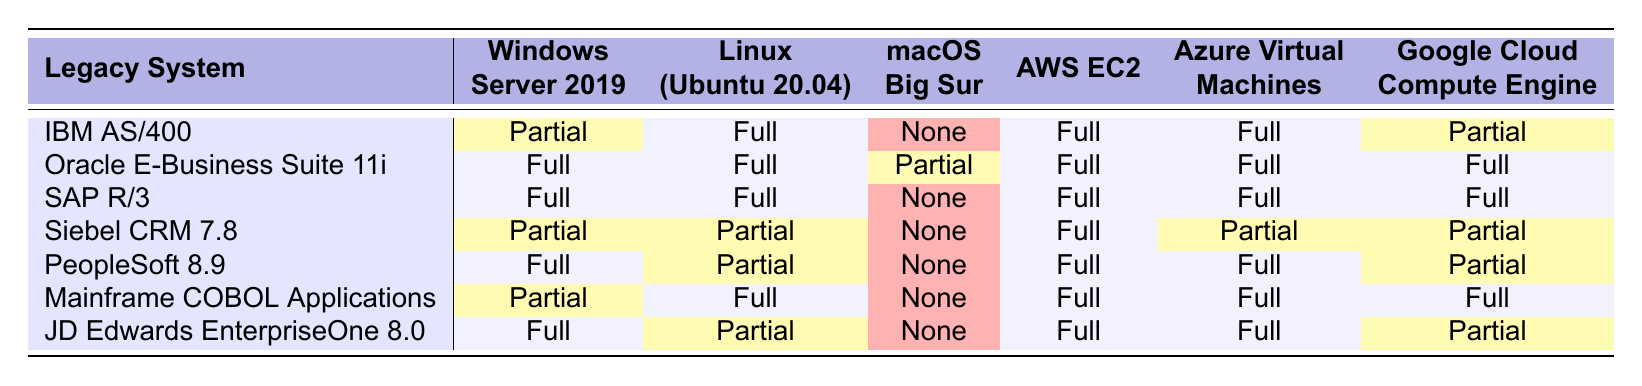What is the compatibility status of the IBM AS/400 with macOS Big Sur? According to the table, the IBM AS/400 shows a compatibility status of "None" with macOS Big Sur.
Answer: None Which legacy system has full compatibility across all modern platforms? Looking through the table, the legacy system Oracle E-Business Suite 11i has "Full" compatibility with all listed modern platforms.
Answer: Oracle E-Business Suite 11i How many legacy systems have partial compatibility with Windows Server 2019? From the table, IBM AS/400, Siebel CRM 7.8, Mainframe COBOL Applications, and JD Edwards EnterpriseOne 8.0 have "Partial" compatibility with Windows Server 2019, making a total of four systems.
Answer: Four Is there any legacy system that is fully compatible with both AWS EC2 and Azure Virtual Machines? By examining the table, we can see that all the systems except Siebel CRM 7.8 and PeopleSoft 8.9 are "Full" with AWS EC2 and Azure Virtual Machines. Hence, SAP R/3, Oracle E-Business Suite 11i, and Mainframe COBOL Applications are examples of such systems.
Answer: Yes What is the total number of legacy systems that have no compatibility with macOS Big Sur? The table indicates the legacy systems IBM AS/400, SAP R/3, Siebel CRM 7.8, PeopleSoft 8.9, Mainframe COBOL Applications, and JD Edwards EnterpriseOne 8.0 with "None" compatibility to macOS Big Sur. This totals to four systems.
Answer: Four Which legacy system has the highest compatibility across all cloud platforms? Upon inspection of AWS EC2, Azure Virtual Machines, and Google Cloud Compute Engine compatibility, Oracle E-Business Suite 11i and SAP R/3 have "Full" compatibility across all these platforms.
Answer: Oracle E-Business Suite 11i and SAP R/3 Are there any legacy systems that only have partial compatibility with both Linux and Azure Virtual Machines? The table shows that Siebel CRM 7.8 and Mainframe COBOL Applications both have "Partial" compatibility with Linux and Azure Virtual Machines, thus confirming the existence of such systems.
Answer: Yes What is the compatibility status of PeopleSoft 8.9 with Linux (Ubuntu 20.04)? The table lists the compatibility status for PeopleSoft 8.9 with Linux (Ubuntu 20.04) as "Partial."
Answer: Partial Which legacy system has the lowest compatibility with modern platforms? Looking at the provided compatibility statuses, IBM AS/400 and Siebel CRM 7.8 exhibit a mix of "Partial" and "None," but both have comparable low compatibility. However, macOS Big Sur shows "None" compatibility for multiple systems. Therefore, based on modern platform compatibility, it can be concluded that IBM AS/400 and Siebel CRM 7.8 are among those with lowest.
Answer: IBM AS/400 and Siebel CRM 7.8 